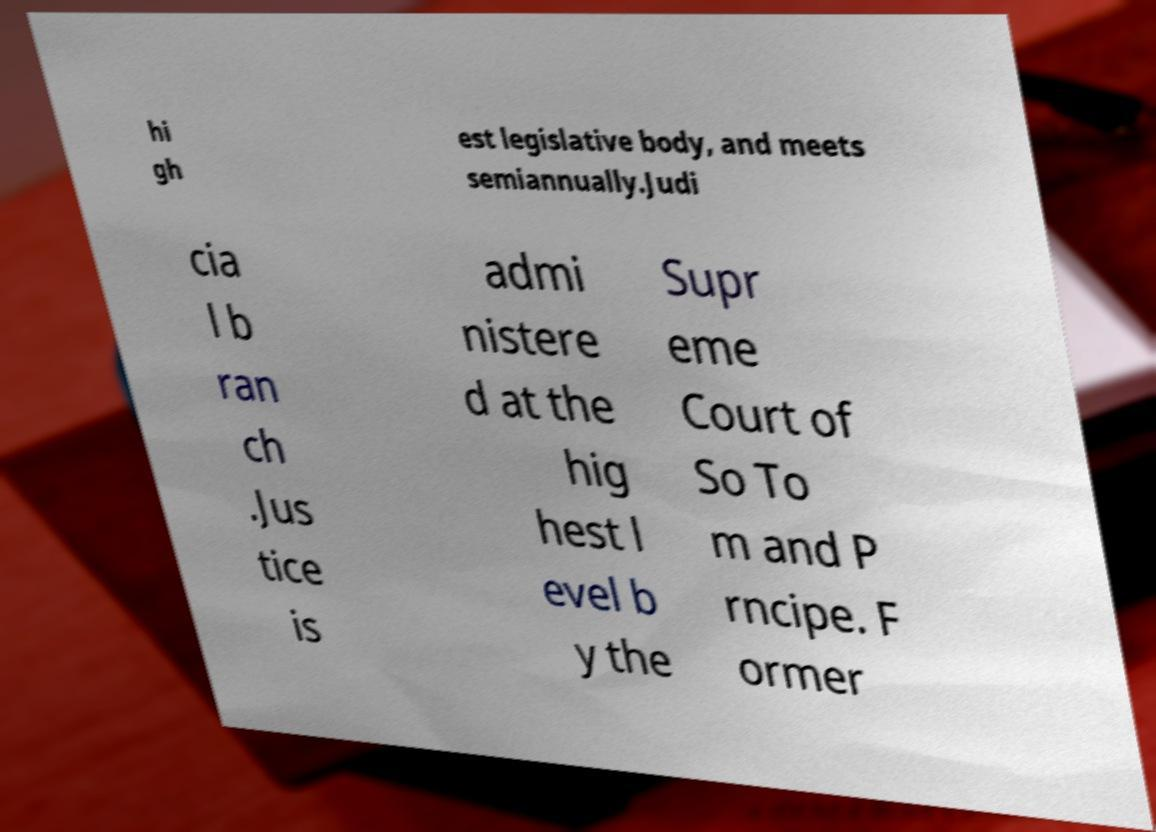Please identify and transcribe the text found in this image. hi gh est legislative body, and meets semiannually.Judi cia l b ran ch .Jus tice is admi nistere d at the hig hest l evel b y the Supr eme Court of So To m and P rncipe. F ormer 